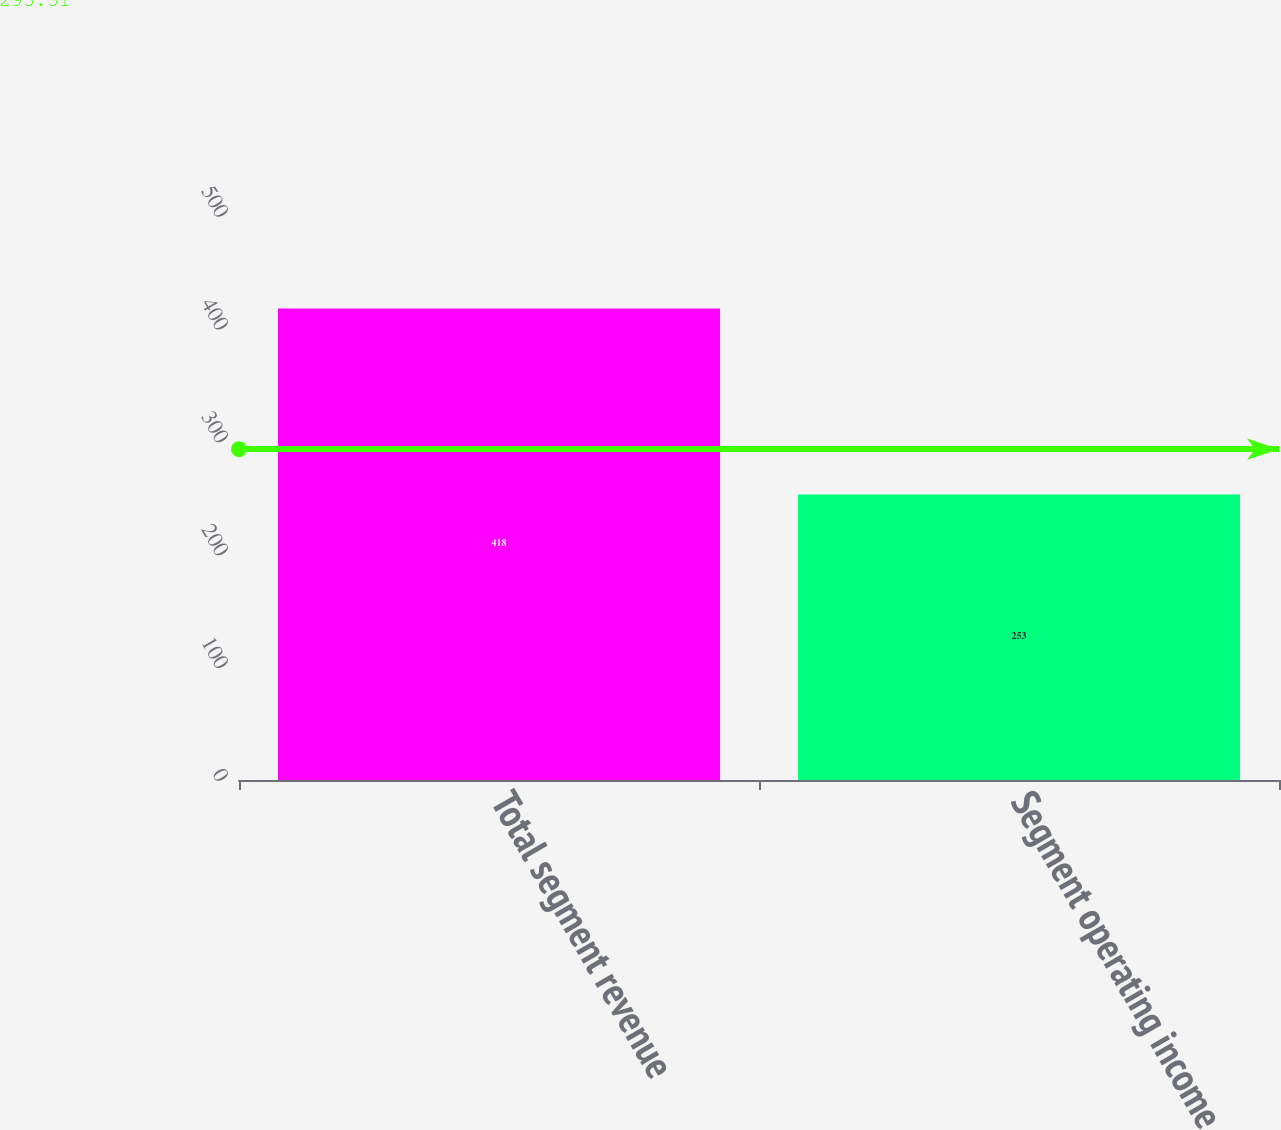Convert chart. <chart><loc_0><loc_0><loc_500><loc_500><bar_chart><fcel>Total segment revenue<fcel>Segment operating income<nl><fcel>418<fcel>253<nl></chart> 